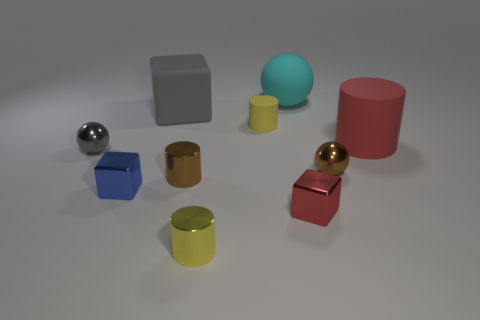There is a brown metallic object that is to the left of the large cyan sphere; what shape is it?
Give a very brief answer. Cylinder. Are there any other things that have the same color as the tiny rubber cylinder?
Provide a succinct answer. Yes. What number of cylinders have the same size as the gray rubber thing?
Ensure brevity in your answer.  1. What shape is the thing that is the same color as the matte block?
Give a very brief answer. Sphere. The red object in front of the metal thing behind the small brown thing to the right of the large cyan rubber sphere is what shape?
Give a very brief answer. Cube. What is the color of the large sphere right of the large gray matte block?
Provide a short and direct response. Cyan. There is a matte cylinder that is the same size as the gray block; what is its color?
Your response must be concise. Red. The tiny cylinder behind the small shiny sphere that is to the left of the yellow cylinder in front of the tiny gray shiny ball is what color?
Make the answer very short. Yellow. There is a gray sphere; is it the same size as the yellow object in front of the small blue metallic object?
Your response must be concise. Yes. Is there a object that has the same material as the red cylinder?
Keep it short and to the point. Yes. 